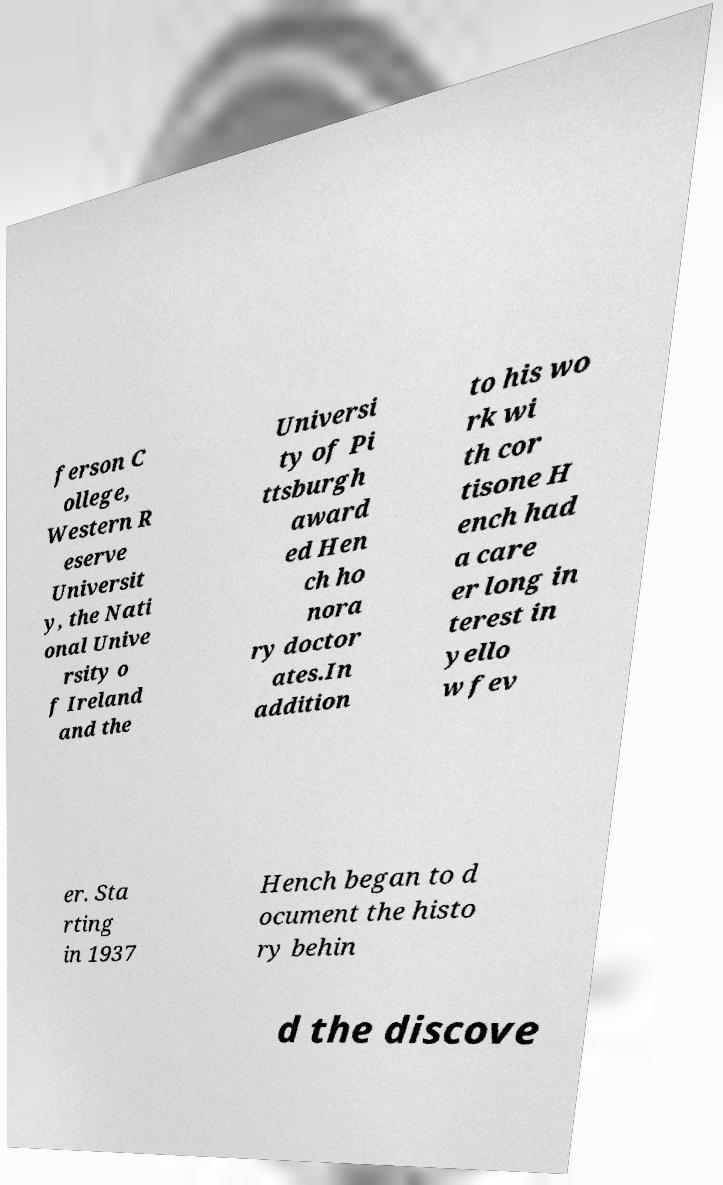What messages or text are displayed in this image? I need them in a readable, typed format. ferson C ollege, Western R eserve Universit y, the Nati onal Unive rsity o f Ireland and the Universi ty of Pi ttsburgh award ed Hen ch ho nora ry doctor ates.In addition to his wo rk wi th cor tisone H ench had a care er long in terest in yello w fev er. Sta rting in 1937 Hench began to d ocument the histo ry behin d the discove 